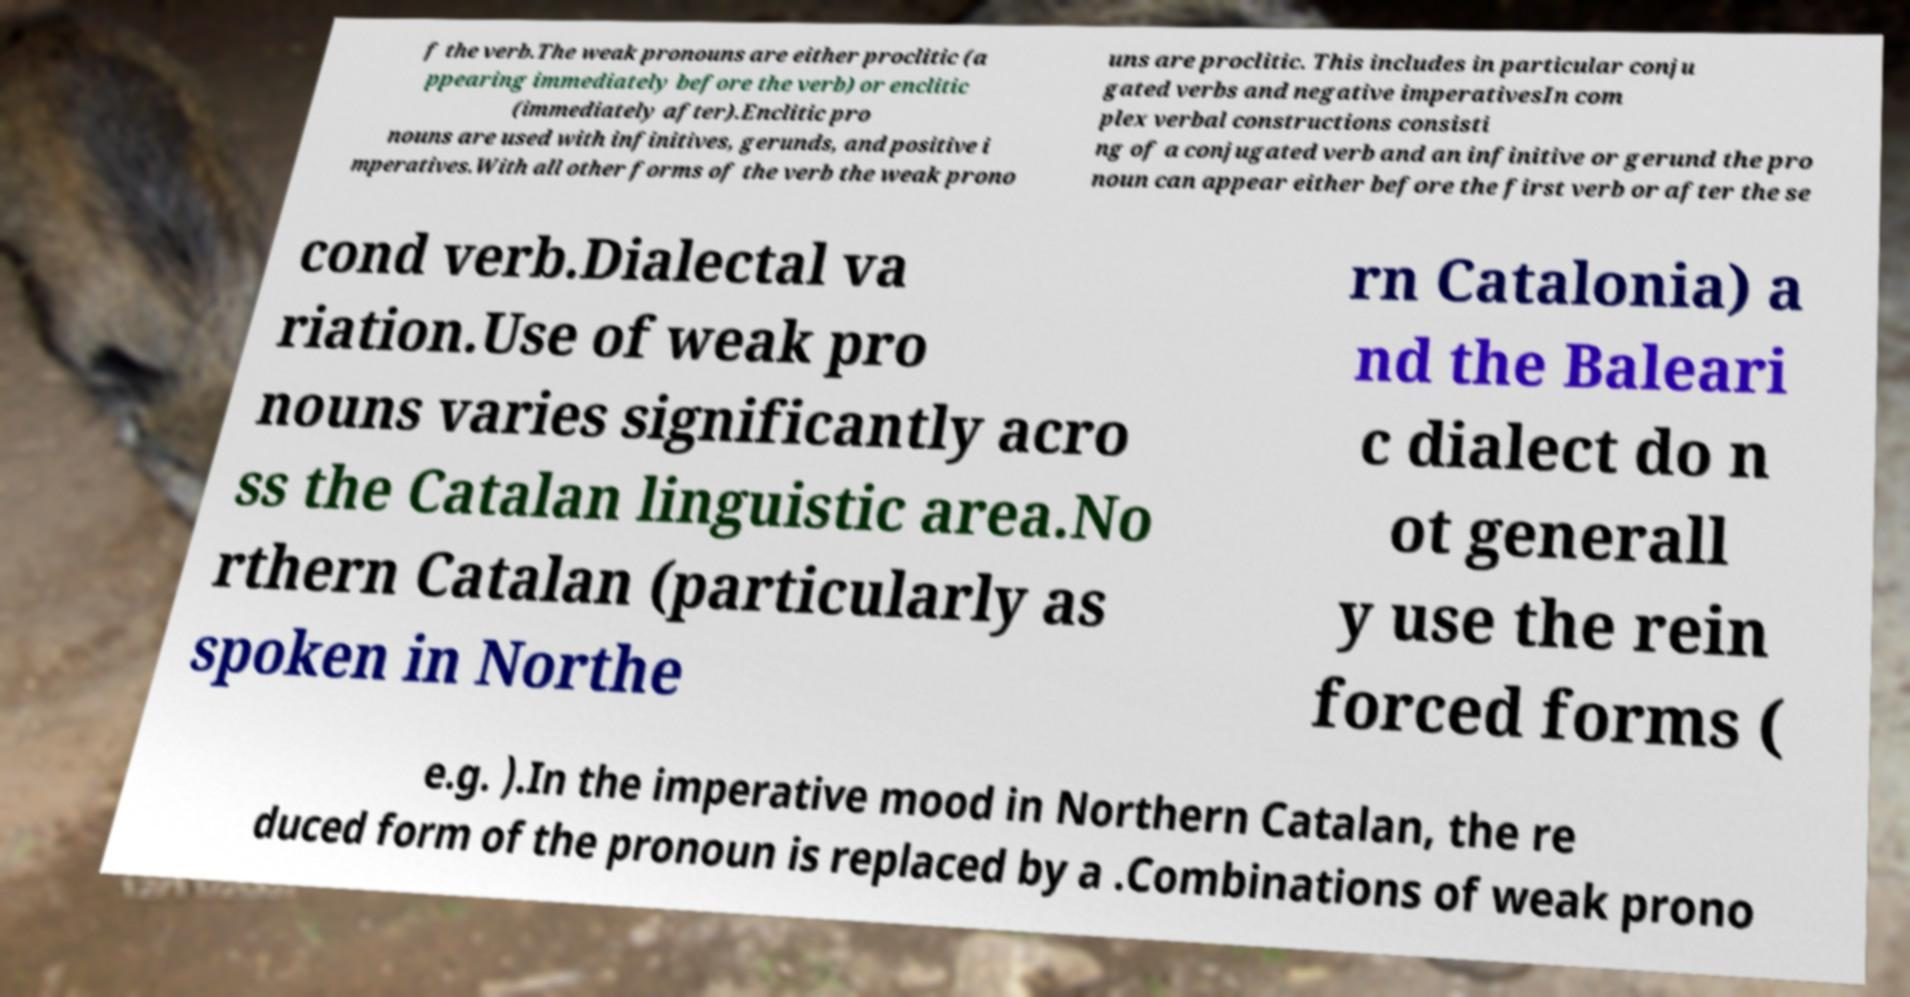Could you assist in decoding the text presented in this image and type it out clearly? f the verb.The weak pronouns are either proclitic (a ppearing immediately before the verb) or enclitic (immediately after).Enclitic pro nouns are used with infinitives, gerunds, and positive i mperatives.With all other forms of the verb the weak prono uns are proclitic. This includes in particular conju gated verbs and negative imperativesIn com plex verbal constructions consisti ng of a conjugated verb and an infinitive or gerund the pro noun can appear either before the first verb or after the se cond verb.Dialectal va riation.Use of weak pro nouns varies significantly acro ss the Catalan linguistic area.No rthern Catalan (particularly as spoken in Northe rn Catalonia) a nd the Baleari c dialect do n ot generall y use the rein forced forms ( e.g. ).In the imperative mood in Northern Catalan, the re duced form of the pronoun is replaced by a .Combinations of weak prono 